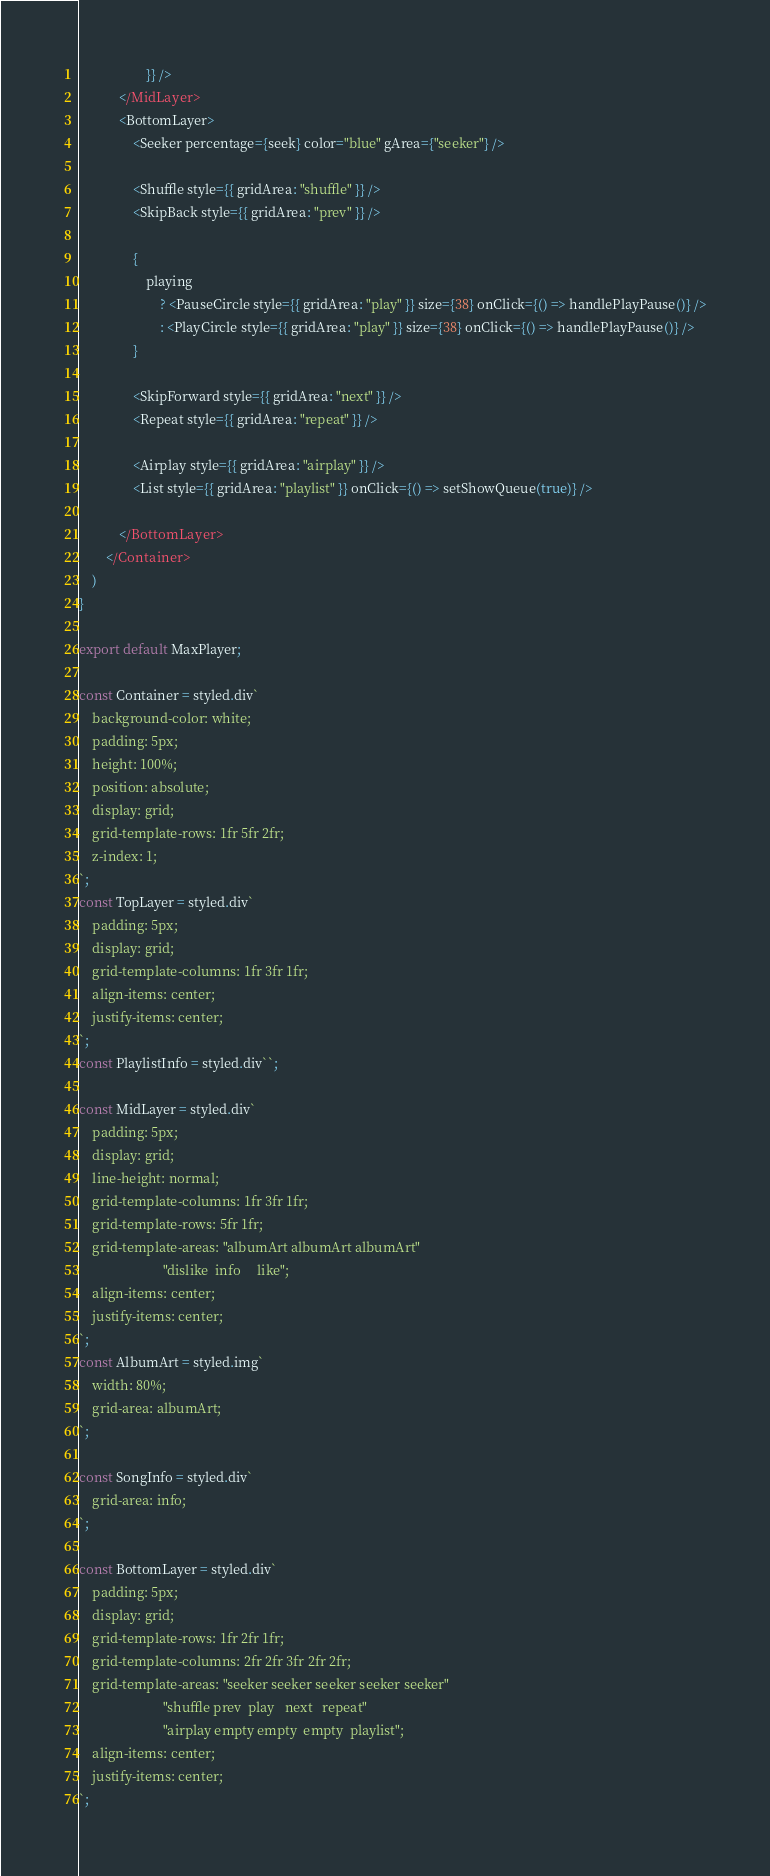Convert code to text. <code><loc_0><loc_0><loc_500><loc_500><_TypeScript_>                    }} />
            </MidLayer>
            <BottomLayer>
                <Seeker percentage={seek} color="blue" gArea={"seeker"} />

                <Shuffle style={{ gridArea: "shuffle" }} />
                <SkipBack style={{ gridArea: "prev" }} />

                {
                    playing
                        ? <PauseCircle style={{ gridArea: "play" }} size={38} onClick={() => handlePlayPause()} />
                        : <PlayCircle style={{ gridArea: "play" }} size={38} onClick={() => handlePlayPause()} />
                }

                <SkipForward style={{ gridArea: "next" }} />
                <Repeat style={{ gridArea: "repeat" }} />

                <Airplay style={{ gridArea: "airplay" }} />
                <List style={{ gridArea: "playlist" }} onClick={() => setShowQueue(true)} />

            </BottomLayer>
        </Container>
    )
}

export default MaxPlayer;

const Container = styled.div`
    background-color: white;
    padding: 5px;
    height: 100%;    
    position: absolute;
    display: grid;
    grid-template-rows: 1fr 5fr 2fr;
    z-index: 1;
`;
const TopLayer = styled.div`
    padding: 5px;    
    display: grid;
    grid-template-columns: 1fr 3fr 1fr;
    align-items: center;
    justify-items: center;
`;
const PlaylistInfo = styled.div``;

const MidLayer = styled.div`
    padding: 5px;
    display: grid;
    line-height: normal;
    grid-template-columns: 1fr 3fr 1fr;
    grid-template-rows: 5fr 1fr;
    grid-template-areas: "albumArt albumArt albumArt"
                         "dislike  info     like";
    align-items: center;
    justify-items: center;
`;
const AlbumArt = styled.img`
    width: 80%;
    grid-area: albumArt;
`;

const SongInfo = styled.div`
    grid-area: info;
`;

const BottomLayer = styled.div`
    padding: 5px;    
    display: grid;
    grid-template-rows: 1fr 2fr 1fr;
    grid-template-columns: 2fr 2fr 3fr 2fr 2fr;
    grid-template-areas: "seeker seeker seeker seeker seeker"
                         "shuffle prev  play   next   repeat"
                         "airplay empty empty  empty  playlist";
    align-items: center;
    justify-items: center;
`;

</code> 